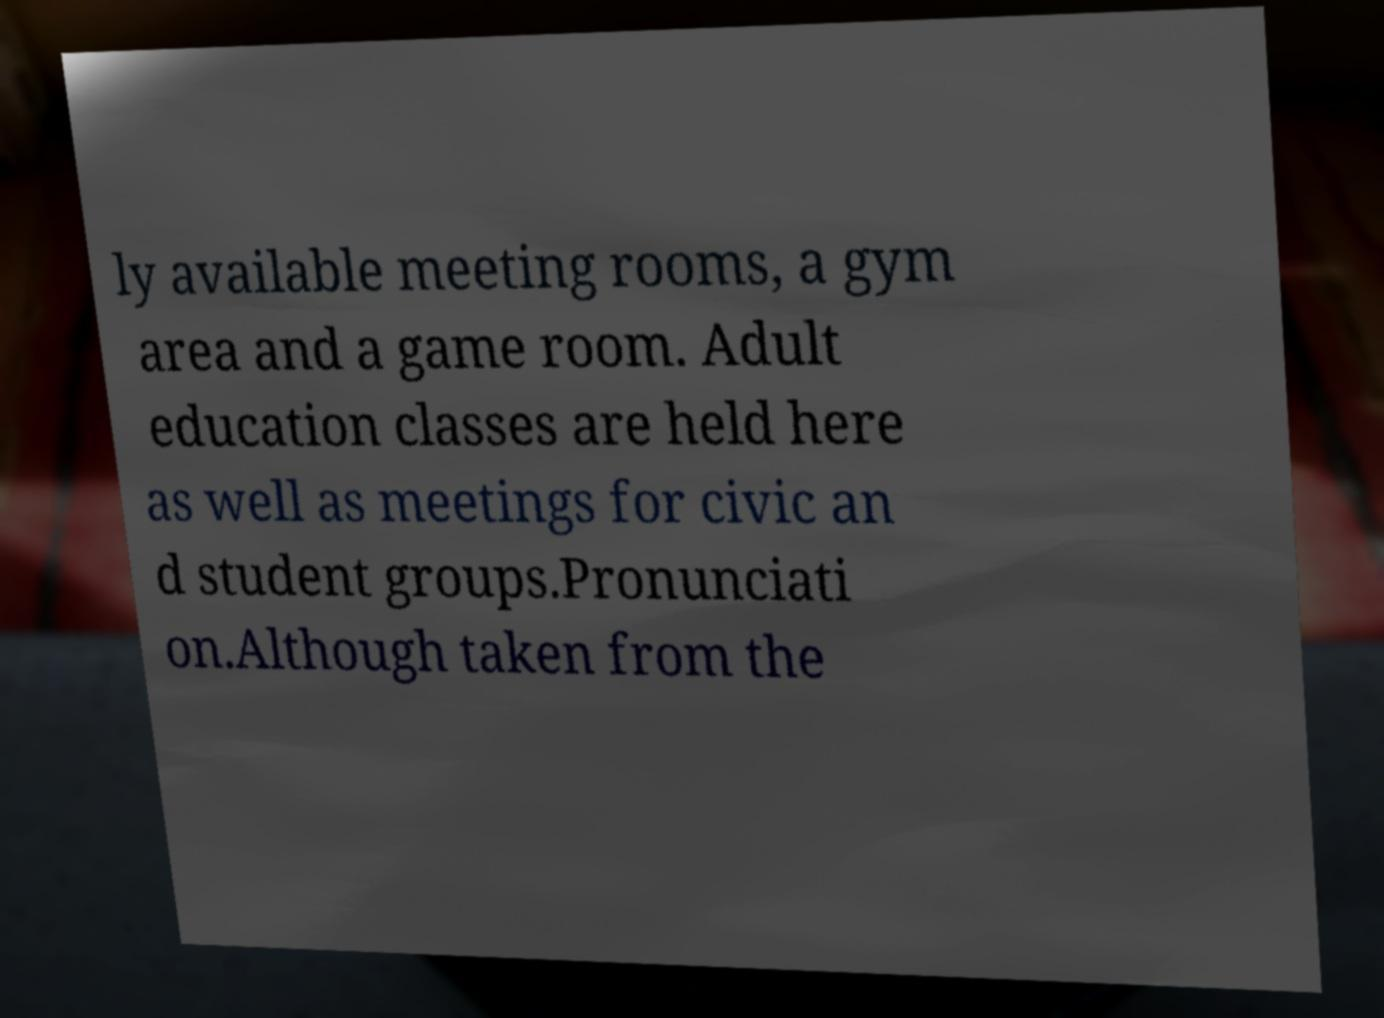For documentation purposes, I need the text within this image transcribed. Could you provide that? ly available meeting rooms, a gym area and a game room. Adult education classes are held here as well as meetings for civic an d student groups.Pronunciati on.Although taken from the 